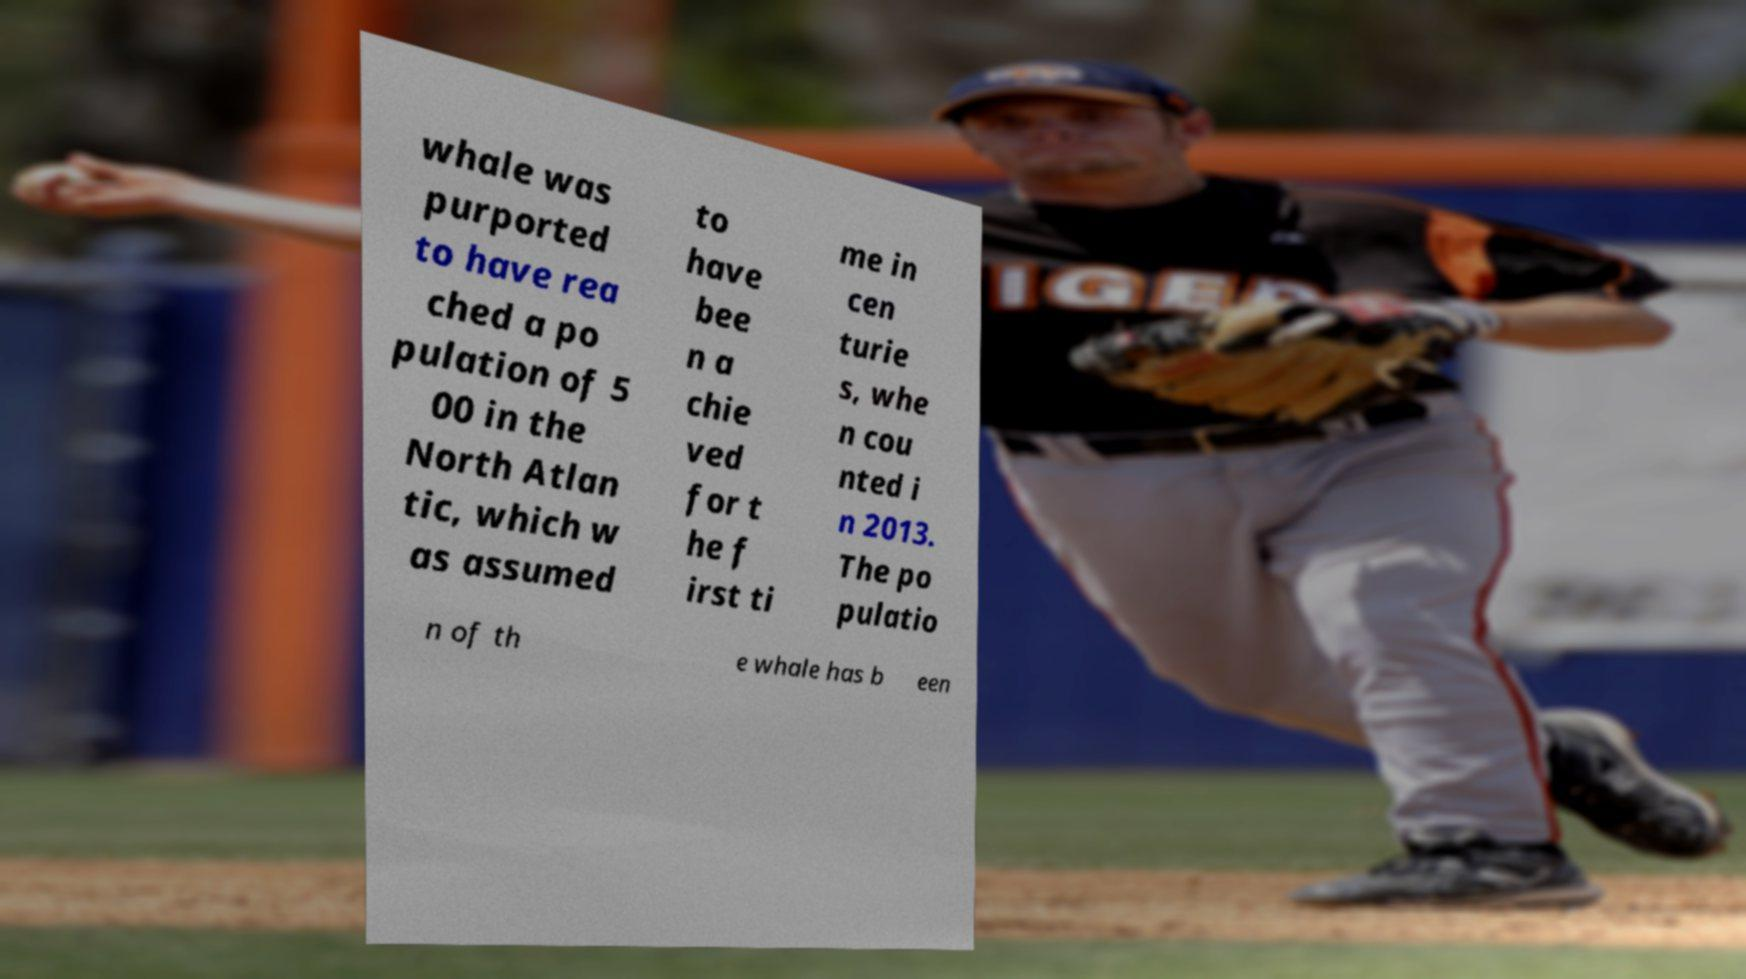Please read and relay the text visible in this image. What does it say? whale was purported to have rea ched a po pulation of 5 00 in the North Atlan tic, which w as assumed to have bee n a chie ved for t he f irst ti me in cen turie s, whe n cou nted i n 2013. The po pulatio n of th e whale has b een 